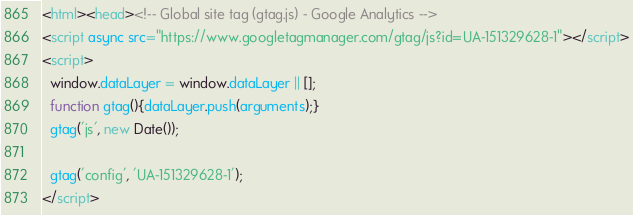<code> <loc_0><loc_0><loc_500><loc_500><_HTML_><html><head><!-- Global site tag (gtag.js) - Google Analytics -->
<script async src="https://www.googletagmanager.com/gtag/js?id=UA-151329628-1"></script>
<script>
  window.dataLayer = window.dataLayer || [];
  function gtag(){dataLayer.push(arguments);}
  gtag('js', new Date());

  gtag('config', 'UA-151329628-1');
</script></code> 